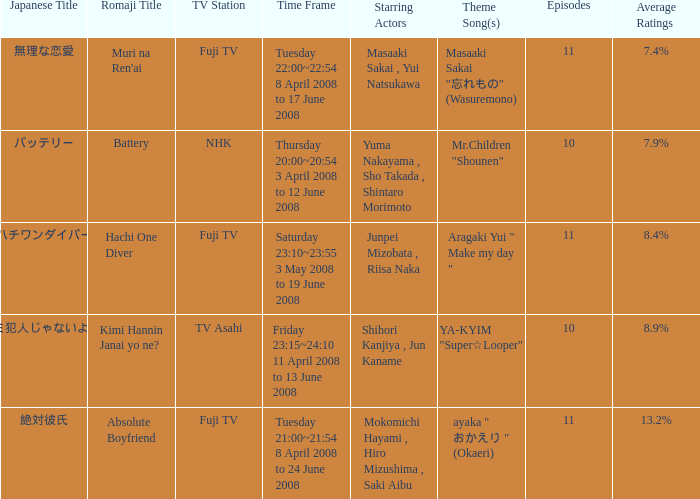What is the average rating for tv asahi? 8.9%. 